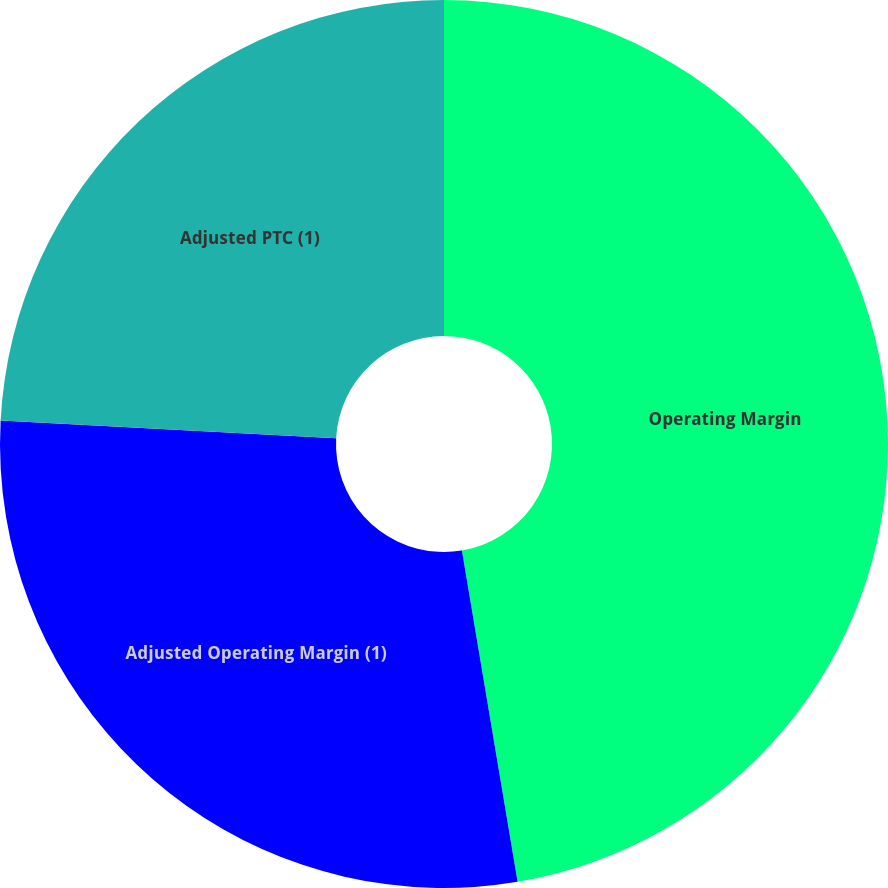<chart> <loc_0><loc_0><loc_500><loc_500><pie_chart><fcel>Operating Margin<fcel>Adjusted Operating Margin (1)<fcel>Adjusted PTC (1)<nl><fcel>47.35%<fcel>28.49%<fcel>24.16%<nl></chart> 